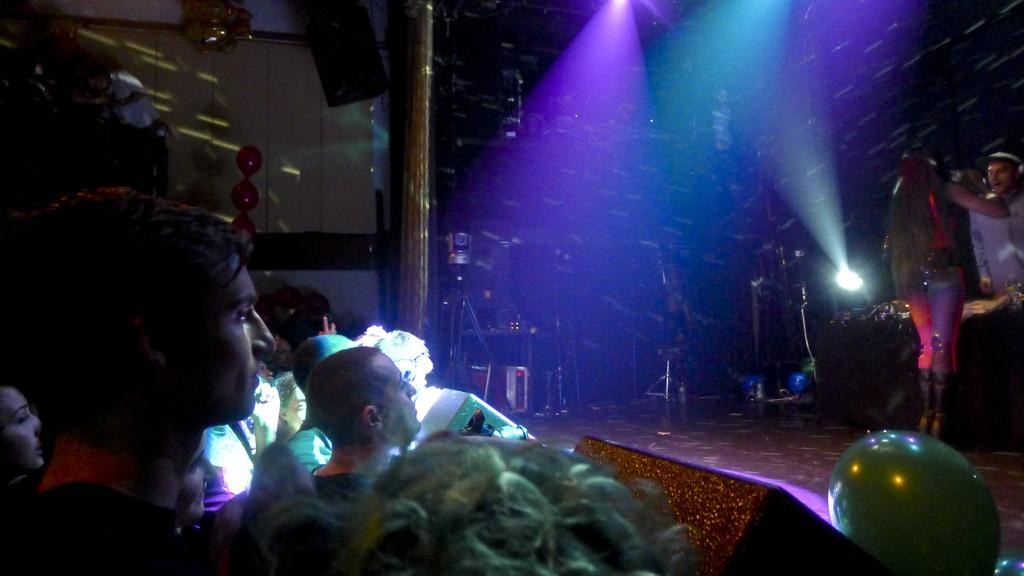What are the people in the image doing? There are people watching in the image, and some people are performing on a dais. What can be seen in the image that provides illumination? There are lights visible in the image. What decorative items are present in the image? There are balloons in the image. What is hanging in the image that might be used for amplifying sound? A speaker is hanging in the image. What type of ball can be seen rolling on the floor in the image? There is no ball visible on the floor in the image. What kind of bean is present in the image? There are no beans present in the image. 